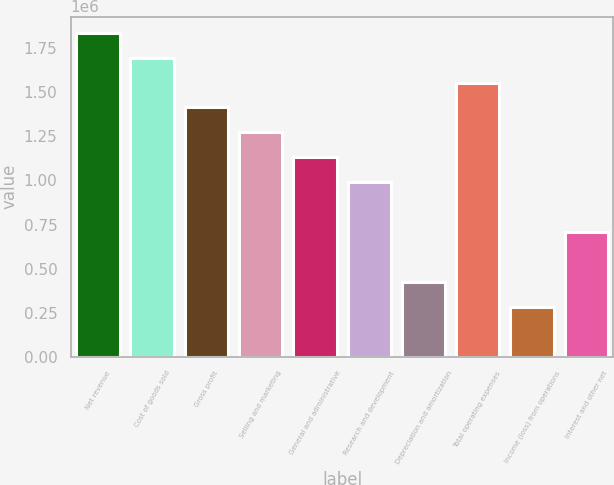Convert chart to OTSL. <chart><loc_0><loc_0><loc_500><loc_500><bar_chart><fcel>Net revenue<fcel>Cost of goods sold<fcel>Gross profit<fcel>Selling and marketing<fcel>General and administrative<fcel>Research and development<fcel>Depreciation and amortization<fcel>Total operating expenses<fcel>Income (loss) from operations<fcel>Interest and other net<nl><fcel>1.837e+06<fcel>1.6959e+06<fcel>1.4137e+06<fcel>1.2726e+06<fcel>1.1315e+06<fcel>990394<fcel>425988<fcel>1.5548e+06<fcel>284886<fcel>708190<nl></chart> 